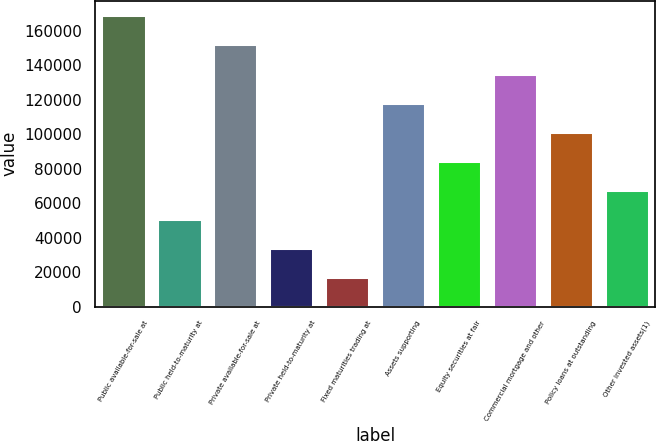<chart> <loc_0><loc_0><loc_500><loc_500><bar_chart><fcel>Public available-for-sale at<fcel>Public held-to-maturity at<fcel>Private available-for-sale at<fcel>Private held-to-maturity at<fcel>Fixed maturities trading at<fcel>Assets supporting<fcel>Equity securities at fair<fcel>Commercial mortgage and other<fcel>Policy loans at outstanding<fcel>Other invested assets(1)<nl><fcel>168991<fcel>50868.1<fcel>152116<fcel>33993.4<fcel>17118.7<fcel>118367<fcel>84617.5<fcel>135242<fcel>101492<fcel>67742.8<nl></chart> 